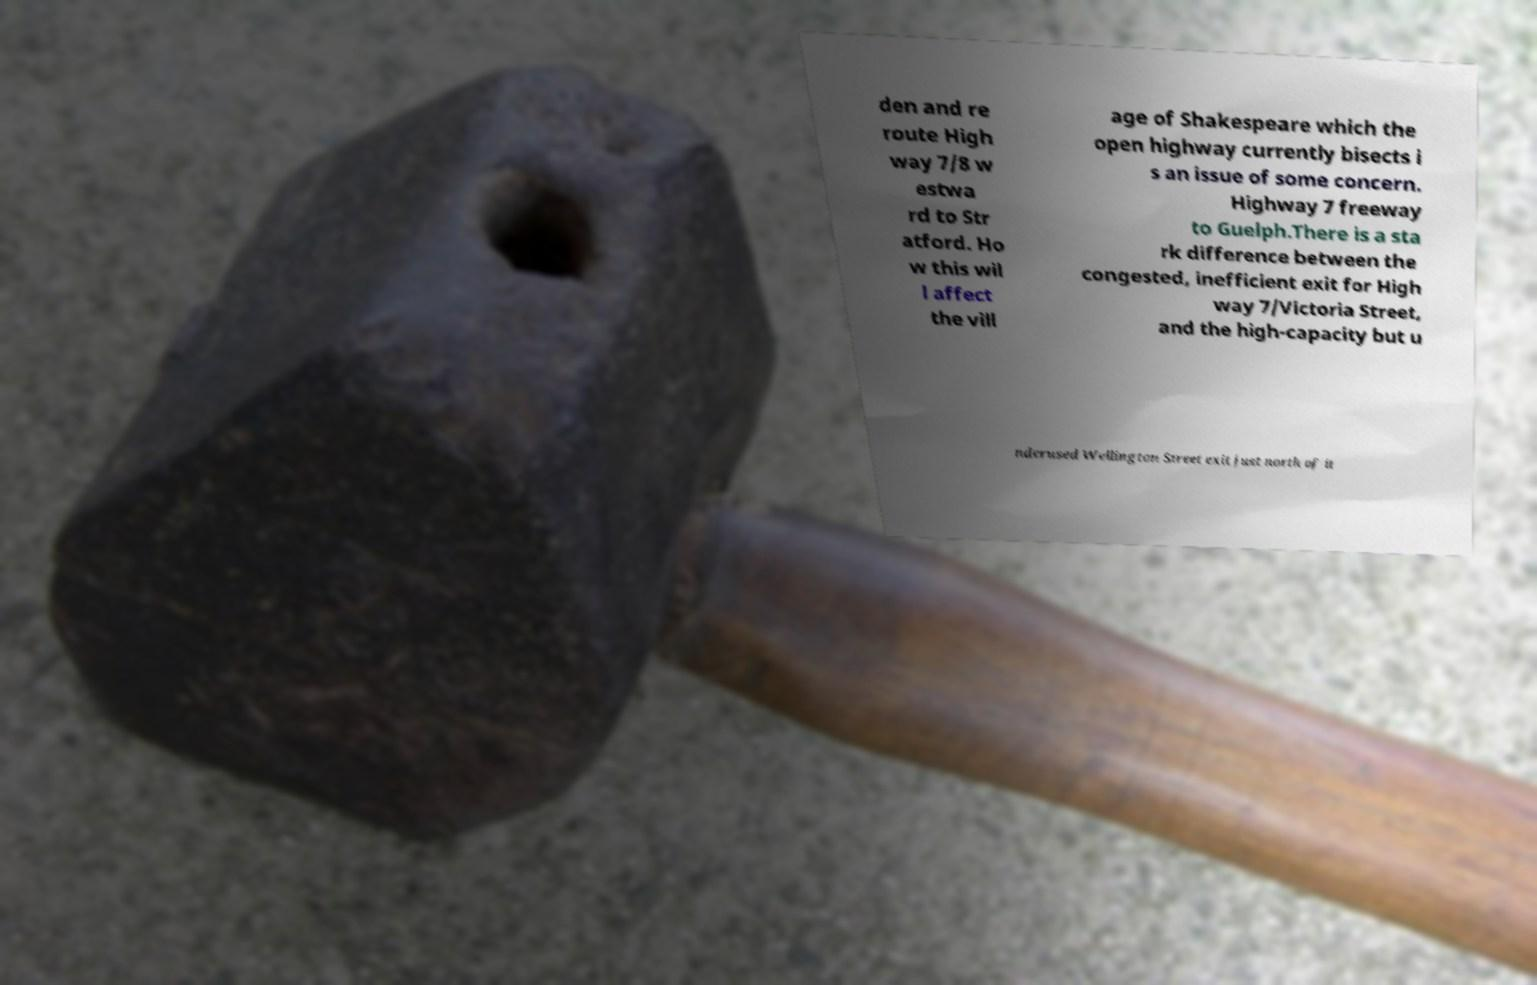What messages or text are displayed in this image? I need them in a readable, typed format. den and re route High way 7/8 w estwa rd to Str atford. Ho w this wil l affect the vill age of Shakespeare which the open highway currently bisects i s an issue of some concern. Highway 7 freeway to Guelph.There is a sta rk difference between the congested, inefficient exit for High way 7/Victoria Street, and the high-capacity but u nderused Wellington Street exit just north of it 